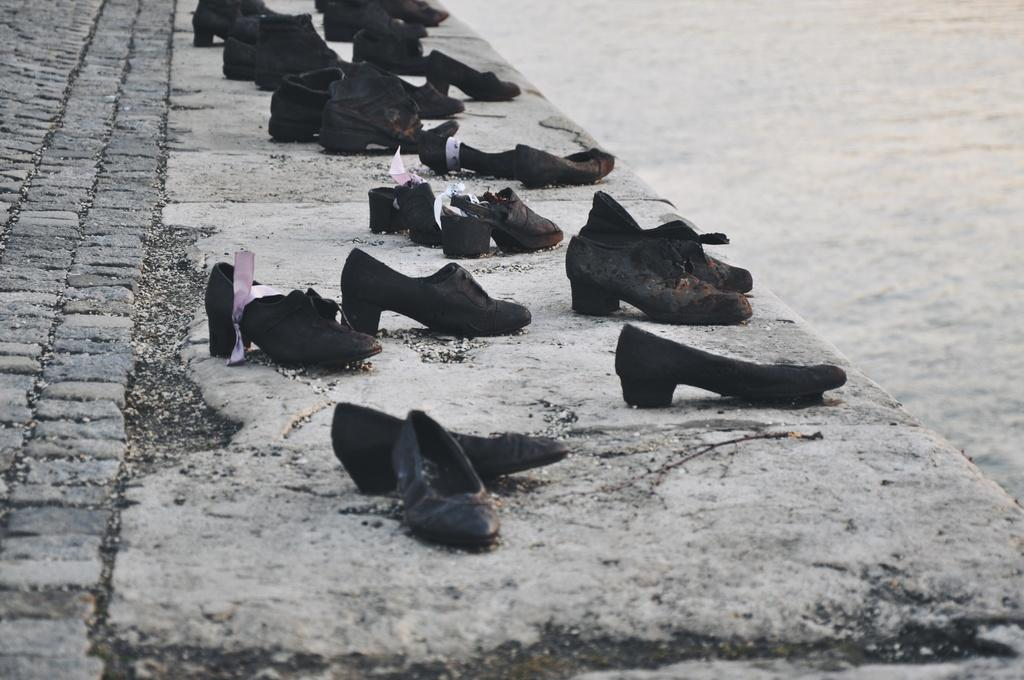What objects are placed on the ground in the image? There are shoes placed on the ground in the image. What can be seen on the right side of the image? There is water visible on the right side of the image. What type of police station can be seen in the image? There is no police station present in the image; it only features shoes placed on the ground and water visible on the right side. 